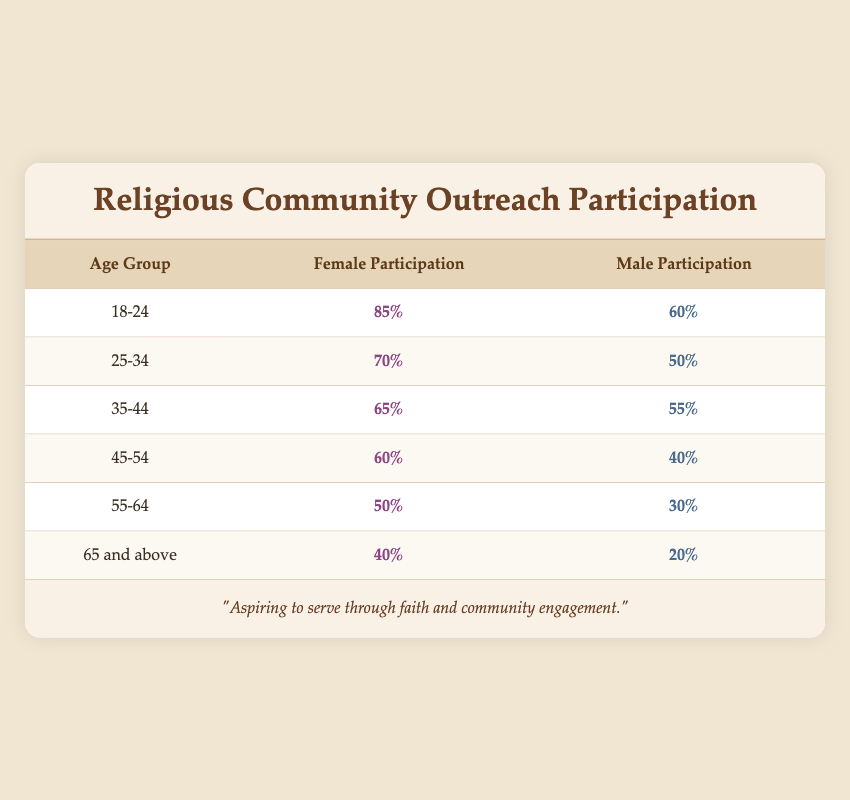What is the participation percentage for females in the 18-24 age group? According to the table, the participation percentage for females in the 18-24 age group is directly listed under the Female Participation column next to that age group, which shows 85%.
Answer: 85% Which age group has the highest male participation? By examining the Male Participation column, the highest value is found in the 18-24 age group at 60%, which is higher than all other male participation percentages in the table.
Answer: 60% What is the difference in participation percentage between females and males in the 35-44 age group? For the 35-44 age group, female participation is 65% and male participation is 55%. The difference can be calculated by subtracting the male participation from the female participation: 65% - 55% = 10%.
Answer: 10% Is the participation percentage for males in the 45-54 age group higher than that in the 55-64 age group? The table shows that the participation for males in the 45-54 age group is 40%, while in the 55-64 age group it is 30%. Since 40% is greater than 30%, the statement is true.
Answer: Yes Which age group has the lowest overall participation rate among both genders? By comparing the participation percentages across the table, in the 65 and above age group, female participation is 40% and male is 20%. The lowest overall participation rate is therefore 20%.
Answer: 20% 